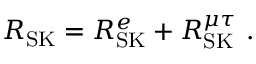Convert formula to latex. <formula><loc_0><loc_0><loc_500><loc_500>R _ { S K } = R _ { S K } ^ { e } + R _ { S K } ^ { \mu \tau } \ .</formula> 